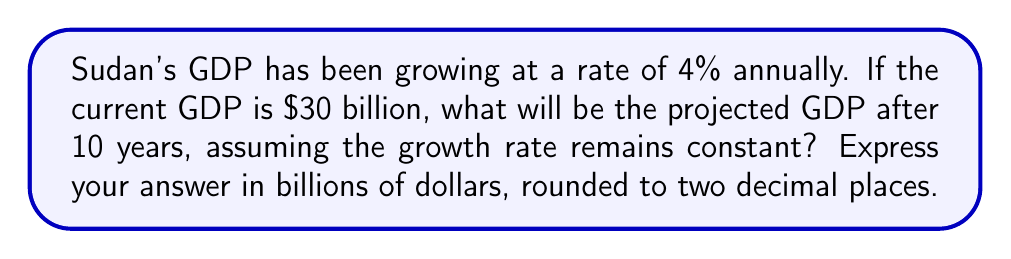Could you help me with this problem? To solve this problem, we'll use the exponential growth formula:

$$A = P(1 + r)^t$$

Where:
$A$ = Final amount
$P$ = Initial principal balance
$r$ = Annual growth rate (as a decimal)
$t$ = Number of years

Given:
$P = 30$ billion dollars
$r = 4\% = 0.04$
$t = 10$ years

Let's substitute these values into the formula:

$$A = 30(1 + 0.04)^{10}$$

Now, let's calculate step by step:

1) First, calculate $(1 + 0.04)$:
   $1 + 0.04 = 1.04$

2) Now, calculate $(1.04)^{10}$:
   $$(1.04)^{10} \approx 1.4802$$

3) Finally, multiply by the initial GDP:
   $$30 \times 1.4802 \approx 44.406$$

4) Rounding to two decimal places:
   $44.41$ billion dollars

Therefore, the projected GDP after 10 years will be approximately $44.41 billion dollars.
Answer: $44.41 billion 